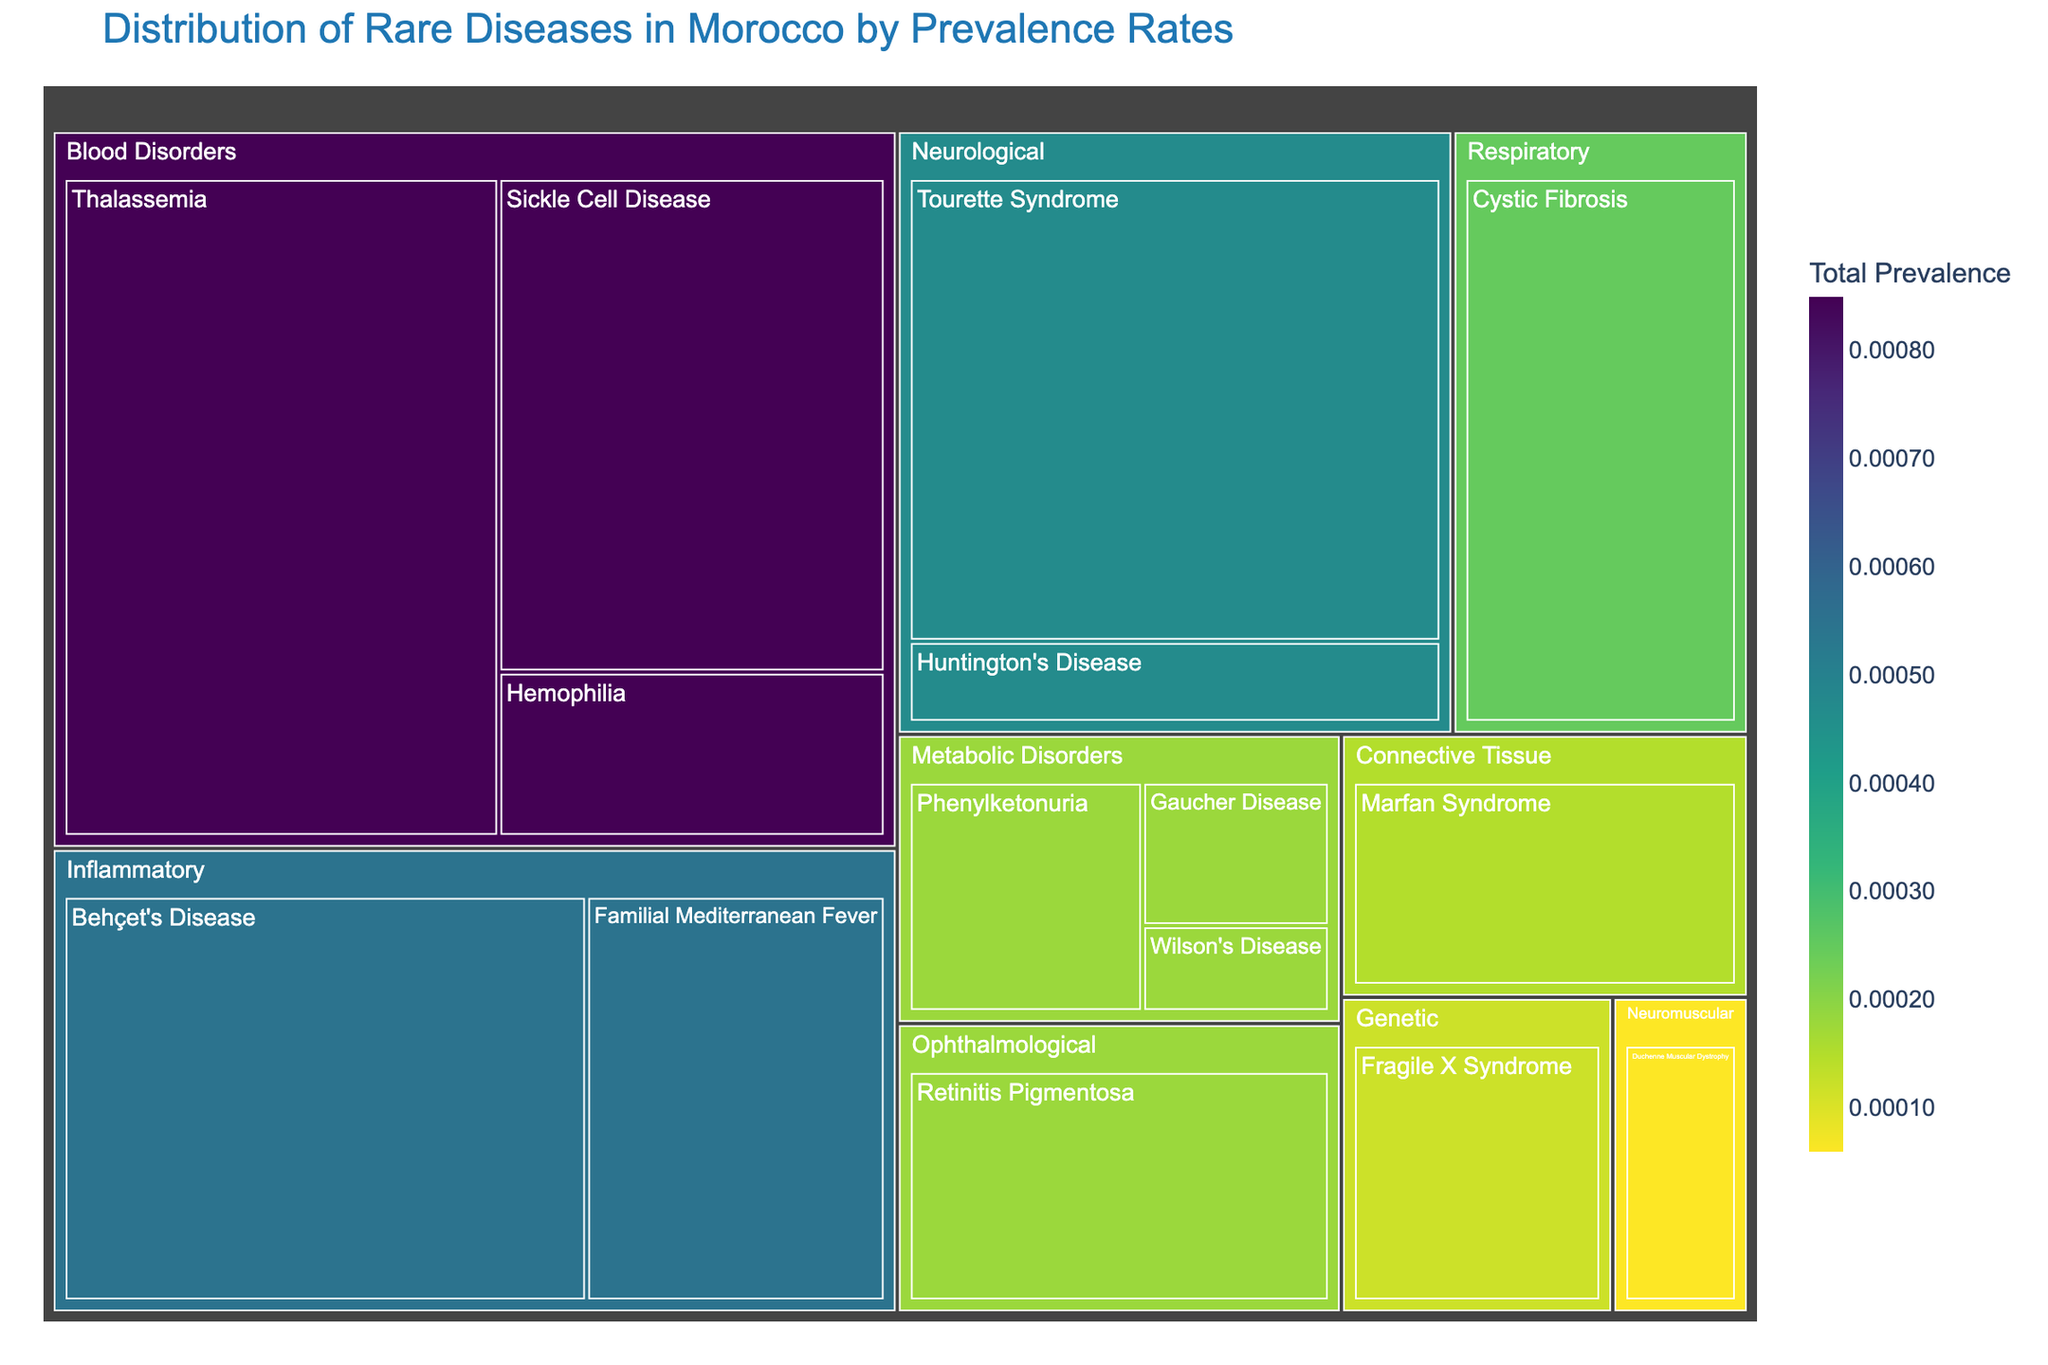Why is Behçet's Disease highlighted in the figure? Behçet's Disease falls under the 'Inflammatory' category and has one of the higher prevalence rates.
Answer: It has a notable prevalence rate of 0.00035 Which category has the highest total prevalence rate? By observing the color intensity, the 'Blood Disorders' category has the darkest color, indicating it has the highest total prevalence rate.
Answer: Blood Disorders How many diseases are there in the 'Metabolic Disorders' category? The treemap shows three separate boxes labeled under 'Metabolic Disorders': Gaucher Disease, Phenylketonuria, and Wilson's Disease.
Answer: 3 What disease under 'Neurological' category has a prevalence rate of 0.0004? The 'Neurological' category includes several diseases, but Tourette Syndrome is the one with a prevalence rate of 0.0004 as displayed in the hover data.
Answer: Tourette Syndrome Compare the prevalence rates of Sickle Cell Disease and Thalassemia. Which one is higher? Observing the chart, the prevalence rate for Sickle Cell Disease is 0.0003 and for Thalassemia is 0.00045.
Answer: Thalassemia What is the total prevalence of rare diseases in the 'Blood Disorders' category? The total prevalence is the sum of the prevalence rates of all diseases under this category: Hemophilia (0.0001) + Sickle Cell Disease (0.0003) + Thalassemia (0.00045).
Answer: 0.00085 Which category has the lowest total prevalence rate and how do you identify it? By looking at the color intensity of the blocks, the least intense color corresponds to the 'Genetic' category, which encompasses the smallest area indicating the lowest prevalence.
Answer: Genetic What is the prevalence rate of Marfan Syndrome and to which category does it belong? Marfan Syndrome is found within the 'Connective Tissue' category, and its prevalence rate is indicated as 0.00015.
Answer: 0.00015 Which category has more diseases: 'Respiratory' or 'Inflammatory'? Observing the treemap, there is only one disease under 'Respiratory', and there are two diseases under 'Inflammatory'.
Answer: Inflammatory 